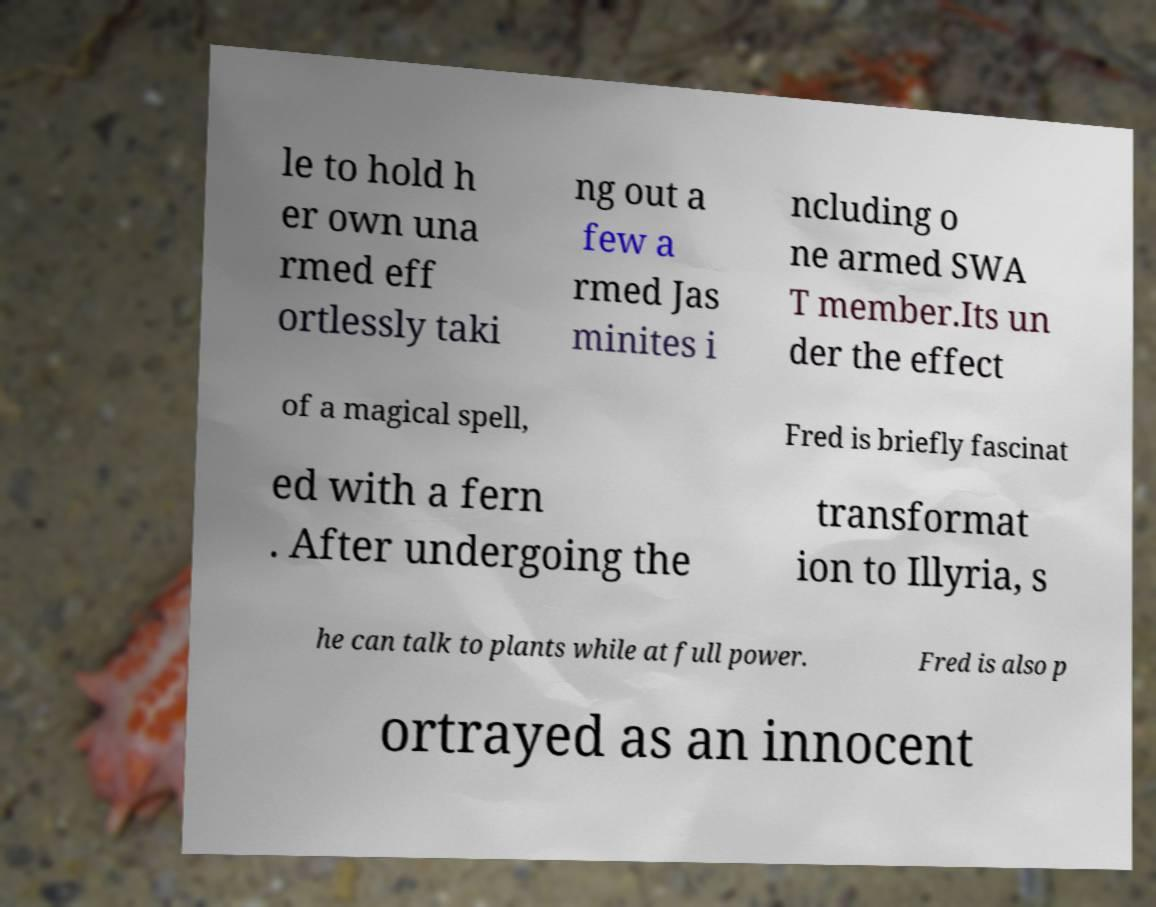Can you accurately transcribe the text from the provided image for me? le to hold h er own una rmed eff ortlessly taki ng out a few a rmed Jas minites i ncluding o ne armed SWA T member.Its un der the effect of a magical spell, Fred is briefly fascinat ed with a fern . After undergoing the transformat ion to Illyria, s he can talk to plants while at full power. Fred is also p ortrayed as an innocent 